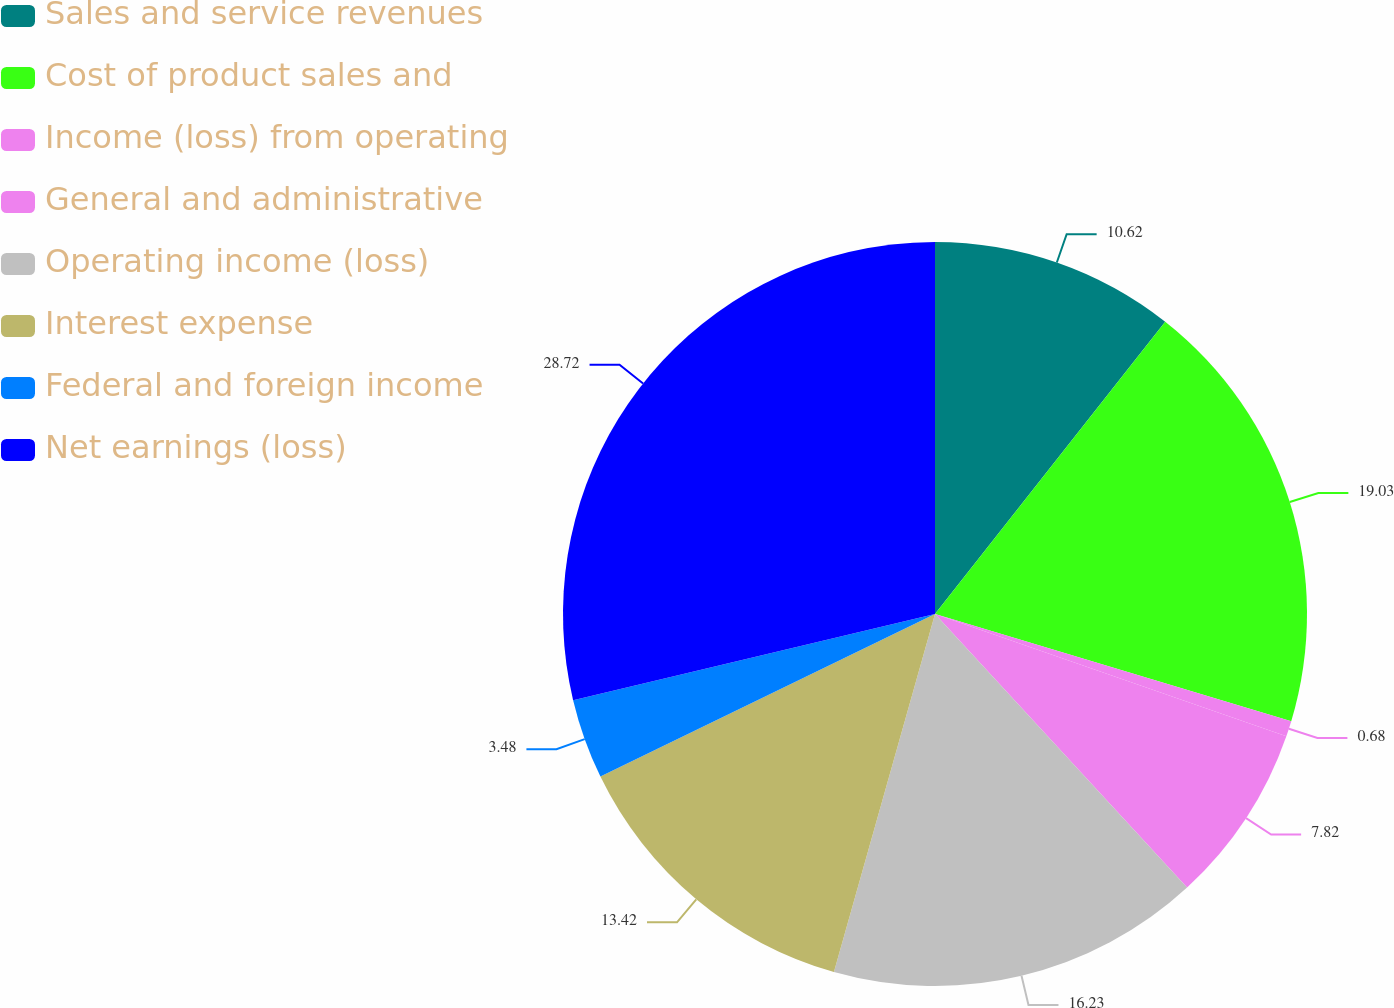Convert chart to OTSL. <chart><loc_0><loc_0><loc_500><loc_500><pie_chart><fcel>Sales and service revenues<fcel>Cost of product sales and<fcel>Income (loss) from operating<fcel>General and administrative<fcel>Operating income (loss)<fcel>Interest expense<fcel>Federal and foreign income<fcel>Net earnings (loss)<nl><fcel>10.62%<fcel>19.03%<fcel>0.68%<fcel>7.82%<fcel>16.23%<fcel>13.42%<fcel>3.48%<fcel>28.72%<nl></chart> 